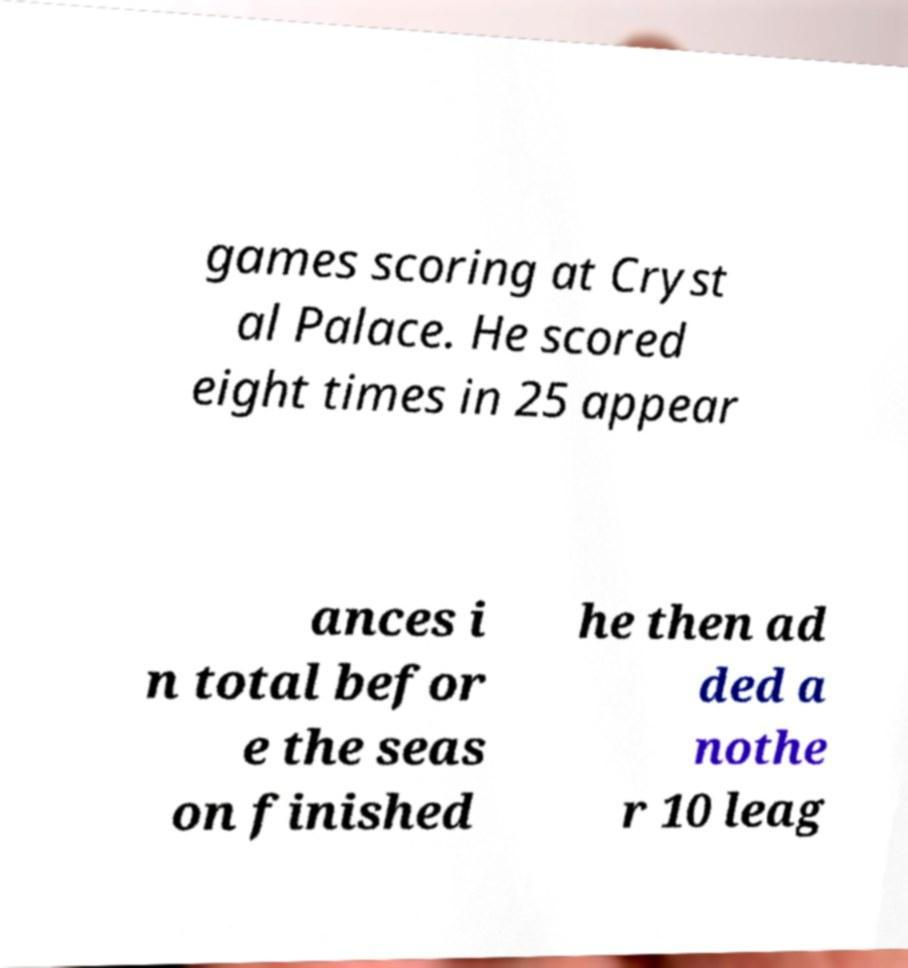Could you assist in decoding the text presented in this image and type it out clearly? games scoring at Cryst al Palace. He scored eight times in 25 appear ances i n total befor e the seas on finished he then ad ded a nothe r 10 leag 